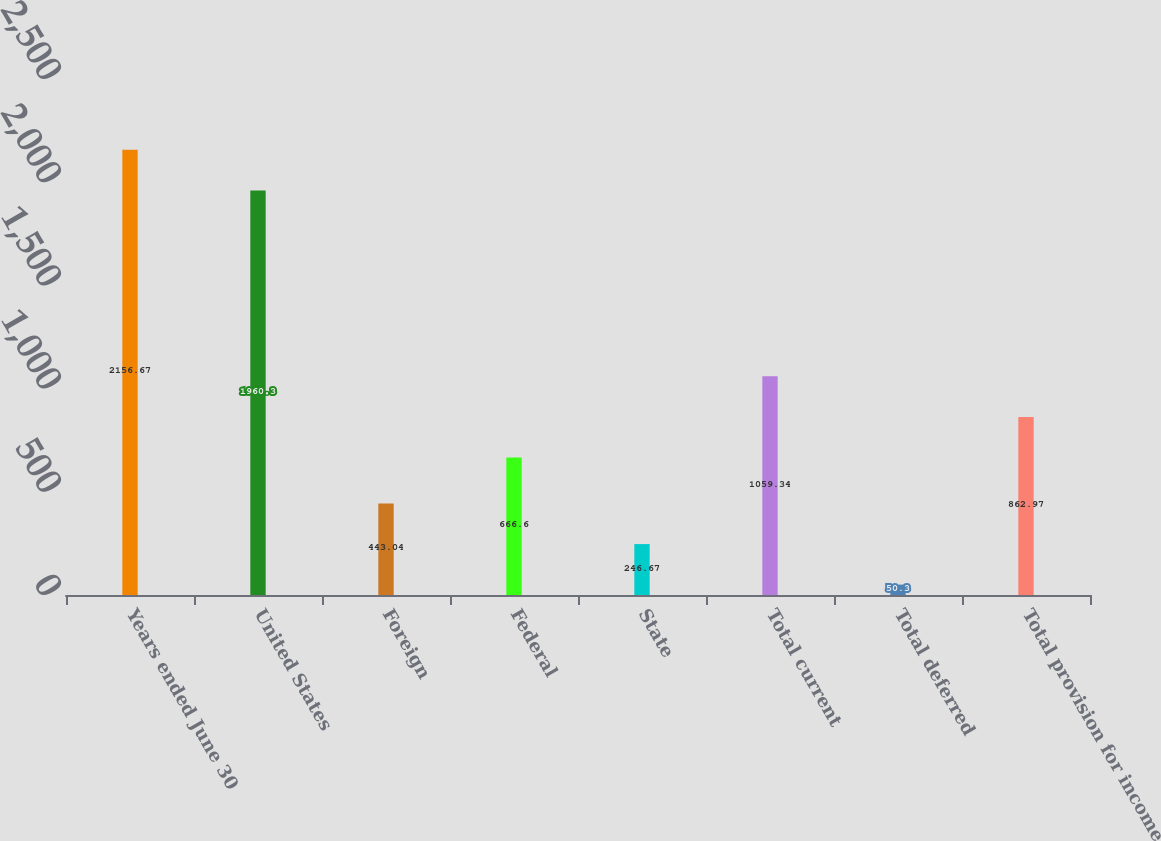Convert chart. <chart><loc_0><loc_0><loc_500><loc_500><bar_chart><fcel>Years ended June 30<fcel>United States<fcel>Foreign<fcel>Federal<fcel>State<fcel>Total current<fcel>Total deferred<fcel>Total provision for income<nl><fcel>2156.67<fcel>1960.3<fcel>443.04<fcel>666.6<fcel>246.67<fcel>1059.34<fcel>50.3<fcel>862.97<nl></chart> 